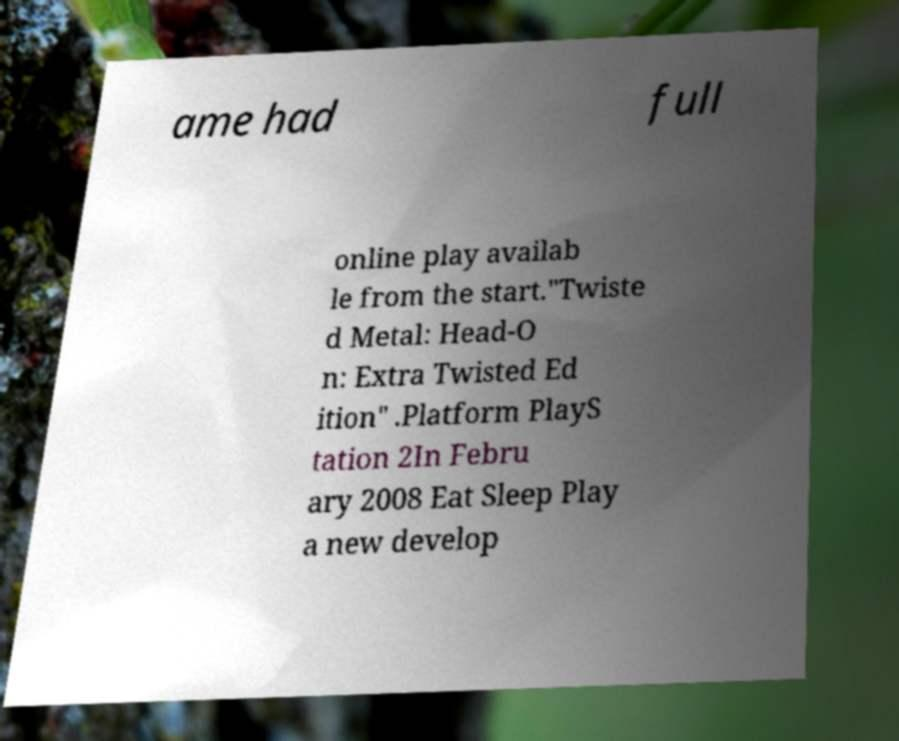Can you accurately transcribe the text from the provided image for me? ame had full online play availab le from the start."Twiste d Metal: Head-O n: Extra Twisted Ed ition" .Platform PlayS tation 2In Febru ary 2008 Eat Sleep Play a new develop 